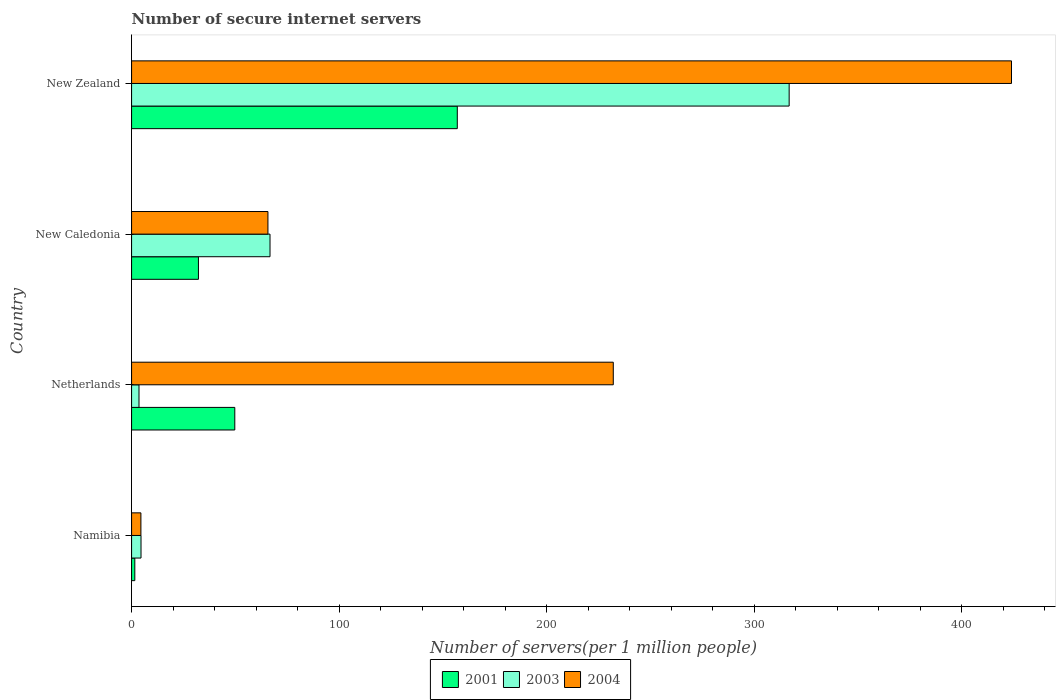How many different coloured bars are there?
Make the answer very short. 3. How many groups of bars are there?
Provide a short and direct response. 4. Are the number of bars per tick equal to the number of legend labels?
Offer a very short reply. Yes. Are the number of bars on each tick of the Y-axis equal?
Offer a terse response. Yes. What is the number of secure internet servers in 2001 in Netherlands?
Give a very brief answer. 49.73. Across all countries, what is the maximum number of secure internet servers in 2001?
Offer a very short reply. 156.94. Across all countries, what is the minimum number of secure internet servers in 2003?
Your answer should be compact. 3.57. In which country was the number of secure internet servers in 2004 maximum?
Provide a short and direct response. New Zealand. In which country was the number of secure internet servers in 2004 minimum?
Offer a very short reply. Namibia. What is the total number of secure internet servers in 2004 in the graph?
Your response must be concise. 726.27. What is the difference between the number of secure internet servers in 2004 in New Caledonia and that in New Zealand?
Make the answer very short. -358.27. What is the difference between the number of secure internet servers in 2003 in New Zealand and the number of secure internet servers in 2001 in Netherlands?
Offer a very short reply. 267.11. What is the average number of secure internet servers in 2001 per country?
Offer a terse response. 60.11. What is the difference between the number of secure internet servers in 2003 and number of secure internet servers in 2004 in Netherlands?
Provide a short and direct response. -228.53. In how many countries, is the number of secure internet servers in 2003 greater than 360 ?
Your answer should be very brief. 0. What is the ratio of the number of secure internet servers in 2004 in Namibia to that in New Zealand?
Give a very brief answer. 0.01. Is the number of secure internet servers in 2003 in Netherlands less than that in New Zealand?
Give a very brief answer. Yes. What is the difference between the highest and the second highest number of secure internet servers in 2004?
Make the answer very short. 191.88. What is the difference between the highest and the lowest number of secure internet servers in 2001?
Your answer should be very brief. 155.38. Are all the bars in the graph horizontal?
Offer a terse response. Yes. Where does the legend appear in the graph?
Offer a very short reply. Bottom center. How are the legend labels stacked?
Make the answer very short. Horizontal. What is the title of the graph?
Ensure brevity in your answer.  Number of secure internet servers. What is the label or title of the X-axis?
Give a very brief answer. Number of servers(per 1 million people). What is the Number of servers(per 1 million people) in 2001 in Namibia?
Ensure brevity in your answer.  1.55. What is the Number of servers(per 1 million people) in 2003 in Namibia?
Give a very brief answer. 4.54. What is the Number of servers(per 1 million people) of 2004 in Namibia?
Offer a very short reply. 4.49. What is the Number of servers(per 1 million people) in 2001 in Netherlands?
Provide a short and direct response. 49.73. What is the Number of servers(per 1 million people) of 2003 in Netherlands?
Keep it short and to the point. 3.57. What is the Number of servers(per 1 million people) in 2004 in Netherlands?
Make the answer very short. 232.1. What is the Number of servers(per 1 million people) in 2001 in New Caledonia?
Your response must be concise. 32.21. What is the Number of servers(per 1 million people) of 2003 in New Caledonia?
Keep it short and to the point. 66.71. What is the Number of servers(per 1 million people) in 2004 in New Caledonia?
Keep it short and to the point. 65.7. What is the Number of servers(per 1 million people) in 2001 in New Zealand?
Provide a succinct answer. 156.94. What is the Number of servers(per 1 million people) of 2003 in New Zealand?
Make the answer very short. 316.85. What is the Number of servers(per 1 million people) of 2004 in New Zealand?
Provide a short and direct response. 423.98. Across all countries, what is the maximum Number of servers(per 1 million people) in 2001?
Provide a succinct answer. 156.94. Across all countries, what is the maximum Number of servers(per 1 million people) of 2003?
Your answer should be very brief. 316.85. Across all countries, what is the maximum Number of servers(per 1 million people) of 2004?
Provide a short and direct response. 423.98. Across all countries, what is the minimum Number of servers(per 1 million people) in 2001?
Provide a succinct answer. 1.55. Across all countries, what is the minimum Number of servers(per 1 million people) in 2003?
Your answer should be compact. 3.57. Across all countries, what is the minimum Number of servers(per 1 million people) in 2004?
Make the answer very short. 4.49. What is the total Number of servers(per 1 million people) of 2001 in the graph?
Offer a terse response. 240.43. What is the total Number of servers(per 1 million people) in 2003 in the graph?
Your answer should be very brief. 391.67. What is the total Number of servers(per 1 million people) in 2004 in the graph?
Your answer should be compact. 726.27. What is the difference between the Number of servers(per 1 million people) in 2001 in Namibia and that in Netherlands?
Keep it short and to the point. -48.18. What is the difference between the Number of servers(per 1 million people) in 2003 in Namibia and that in Netherlands?
Provide a succinct answer. 0.97. What is the difference between the Number of servers(per 1 million people) in 2004 in Namibia and that in Netherlands?
Offer a very short reply. -227.61. What is the difference between the Number of servers(per 1 million people) of 2001 in Namibia and that in New Caledonia?
Offer a terse response. -30.66. What is the difference between the Number of servers(per 1 million people) of 2003 in Namibia and that in New Caledonia?
Offer a terse response. -62.16. What is the difference between the Number of servers(per 1 million people) of 2004 in Namibia and that in New Caledonia?
Provide a succinct answer. -61.21. What is the difference between the Number of servers(per 1 million people) of 2001 in Namibia and that in New Zealand?
Your response must be concise. -155.38. What is the difference between the Number of servers(per 1 million people) of 2003 in Namibia and that in New Zealand?
Your answer should be very brief. -312.3. What is the difference between the Number of servers(per 1 million people) of 2004 in Namibia and that in New Zealand?
Offer a very short reply. -419.48. What is the difference between the Number of servers(per 1 million people) in 2001 in Netherlands and that in New Caledonia?
Keep it short and to the point. 17.52. What is the difference between the Number of servers(per 1 million people) in 2003 in Netherlands and that in New Caledonia?
Offer a terse response. -63.13. What is the difference between the Number of servers(per 1 million people) in 2004 in Netherlands and that in New Caledonia?
Give a very brief answer. 166.4. What is the difference between the Number of servers(per 1 million people) in 2001 in Netherlands and that in New Zealand?
Keep it short and to the point. -107.21. What is the difference between the Number of servers(per 1 million people) of 2003 in Netherlands and that in New Zealand?
Provide a short and direct response. -313.27. What is the difference between the Number of servers(per 1 million people) in 2004 in Netherlands and that in New Zealand?
Offer a very short reply. -191.88. What is the difference between the Number of servers(per 1 million people) of 2001 in New Caledonia and that in New Zealand?
Ensure brevity in your answer.  -124.73. What is the difference between the Number of servers(per 1 million people) in 2003 in New Caledonia and that in New Zealand?
Offer a terse response. -250.14. What is the difference between the Number of servers(per 1 million people) in 2004 in New Caledonia and that in New Zealand?
Keep it short and to the point. -358.27. What is the difference between the Number of servers(per 1 million people) of 2001 in Namibia and the Number of servers(per 1 million people) of 2003 in Netherlands?
Ensure brevity in your answer.  -2.02. What is the difference between the Number of servers(per 1 million people) in 2001 in Namibia and the Number of servers(per 1 million people) in 2004 in Netherlands?
Provide a short and direct response. -230.55. What is the difference between the Number of servers(per 1 million people) of 2003 in Namibia and the Number of servers(per 1 million people) of 2004 in Netherlands?
Offer a very short reply. -227.56. What is the difference between the Number of servers(per 1 million people) of 2001 in Namibia and the Number of servers(per 1 million people) of 2003 in New Caledonia?
Ensure brevity in your answer.  -65.15. What is the difference between the Number of servers(per 1 million people) of 2001 in Namibia and the Number of servers(per 1 million people) of 2004 in New Caledonia?
Your answer should be compact. -64.15. What is the difference between the Number of servers(per 1 million people) in 2003 in Namibia and the Number of servers(per 1 million people) in 2004 in New Caledonia?
Your answer should be very brief. -61.16. What is the difference between the Number of servers(per 1 million people) in 2001 in Namibia and the Number of servers(per 1 million people) in 2003 in New Zealand?
Make the answer very short. -315.29. What is the difference between the Number of servers(per 1 million people) of 2001 in Namibia and the Number of servers(per 1 million people) of 2004 in New Zealand?
Your answer should be very brief. -422.42. What is the difference between the Number of servers(per 1 million people) in 2003 in Namibia and the Number of servers(per 1 million people) in 2004 in New Zealand?
Offer a terse response. -419.43. What is the difference between the Number of servers(per 1 million people) of 2001 in Netherlands and the Number of servers(per 1 million people) of 2003 in New Caledonia?
Keep it short and to the point. -16.97. What is the difference between the Number of servers(per 1 million people) of 2001 in Netherlands and the Number of servers(per 1 million people) of 2004 in New Caledonia?
Offer a very short reply. -15.97. What is the difference between the Number of servers(per 1 million people) in 2003 in Netherlands and the Number of servers(per 1 million people) in 2004 in New Caledonia?
Your answer should be very brief. -62.13. What is the difference between the Number of servers(per 1 million people) of 2001 in Netherlands and the Number of servers(per 1 million people) of 2003 in New Zealand?
Ensure brevity in your answer.  -267.11. What is the difference between the Number of servers(per 1 million people) in 2001 in Netherlands and the Number of servers(per 1 million people) in 2004 in New Zealand?
Keep it short and to the point. -374.24. What is the difference between the Number of servers(per 1 million people) of 2003 in Netherlands and the Number of servers(per 1 million people) of 2004 in New Zealand?
Your answer should be compact. -420.4. What is the difference between the Number of servers(per 1 million people) of 2001 in New Caledonia and the Number of servers(per 1 million people) of 2003 in New Zealand?
Give a very brief answer. -284.64. What is the difference between the Number of servers(per 1 million people) in 2001 in New Caledonia and the Number of servers(per 1 million people) in 2004 in New Zealand?
Ensure brevity in your answer.  -391.77. What is the difference between the Number of servers(per 1 million people) of 2003 in New Caledonia and the Number of servers(per 1 million people) of 2004 in New Zealand?
Make the answer very short. -357.27. What is the average Number of servers(per 1 million people) in 2001 per country?
Offer a terse response. 60.11. What is the average Number of servers(per 1 million people) of 2003 per country?
Keep it short and to the point. 97.92. What is the average Number of servers(per 1 million people) of 2004 per country?
Provide a short and direct response. 181.57. What is the difference between the Number of servers(per 1 million people) in 2001 and Number of servers(per 1 million people) in 2003 in Namibia?
Make the answer very short. -2.99. What is the difference between the Number of servers(per 1 million people) of 2001 and Number of servers(per 1 million people) of 2004 in Namibia?
Provide a short and direct response. -2.94. What is the difference between the Number of servers(per 1 million people) of 2003 and Number of servers(per 1 million people) of 2004 in Namibia?
Offer a terse response. 0.05. What is the difference between the Number of servers(per 1 million people) of 2001 and Number of servers(per 1 million people) of 2003 in Netherlands?
Your response must be concise. 46.16. What is the difference between the Number of servers(per 1 million people) of 2001 and Number of servers(per 1 million people) of 2004 in Netherlands?
Keep it short and to the point. -182.37. What is the difference between the Number of servers(per 1 million people) of 2003 and Number of servers(per 1 million people) of 2004 in Netherlands?
Offer a terse response. -228.53. What is the difference between the Number of servers(per 1 million people) in 2001 and Number of servers(per 1 million people) in 2003 in New Caledonia?
Your answer should be compact. -34.5. What is the difference between the Number of servers(per 1 million people) of 2001 and Number of servers(per 1 million people) of 2004 in New Caledonia?
Provide a short and direct response. -33.49. What is the difference between the Number of servers(per 1 million people) of 2001 and Number of servers(per 1 million people) of 2003 in New Zealand?
Provide a succinct answer. -159.91. What is the difference between the Number of servers(per 1 million people) of 2001 and Number of servers(per 1 million people) of 2004 in New Zealand?
Your answer should be very brief. -267.04. What is the difference between the Number of servers(per 1 million people) in 2003 and Number of servers(per 1 million people) in 2004 in New Zealand?
Provide a succinct answer. -107.13. What is the ratio of the Number of servers(per 1 million people) of 2001 in Namibia to that in Netherlands?
Your answer should be very brief. 0.03. What is the ratio of the Number of servers(per 1 million people) in 2003 in Namibia to that in Netherlands?
Your response must be concise. 1.27. What is the ratio of the Number of servers(per 1 million people) of 2004 in Namibia to that in Netherlands?
Ensure brevity in your answer.  0.02. What is the ratio of the Number of servers(per 1 million people) of 2001 in Namibia to that in New Caledonia?
Provide a short and direct response. 0.05. What is the ratio of the Number of servers(per 1 million people) of 2003 in Namibia to that in New Caledonia?
Your response must be concise. 0.07. What is the ratio of the Number of servers(per 1 million people) of 2004 in Namibia to that in New Caledonia?
Ensure brevity in your answer.  0.07. What is the ratio of the Number of servers(per 1 million people) of 2001 in Namibia to that in New Zealand?
Offer a terse response. 0.01. What is the ratio of the Number of servers(per 1 million people) in 2003 in Namibia to that in New Zealand?
Offer a terse response. 0.01. What is the ratio of the Number of servers(per 1 million people) of 2004 in Namibia to that in New Zealand?
Make the answer very short. 0.01. What is the ratio of the Number of servers(per 1 million people) of 2001 in Netherlands to that in New Caledonia?
Keep it short and to the point. 1.54. What is the ratio of the Number of servers(per 1 million people) in 2003 in Netherlands to that in New Caledonia?
Ensure brevity in your answer.  0.05. What is the ratio of the Number of servers(per 1 million people) of 2004 in Netherlands to that in New Caledonia?
Your answer should be compact. 3.53. What is the ratio of the Number of servers(per 1 million people) in 2001 in Netherlands to that in New Zealand?
Your answer should be very brief. 0.32. What is the ratio of the Number of servers(per 1 million people) of 2003 in Netherlands to that in New Zealand?
Offer a terse response. 0.01. What is the ratio of the Number of servers(per 1 million people) in 2004 in Netherlands to that in New Zealand?
Your response must be concise. 0.55. What is the ratio of the Number of servers(per 1 million people) in 2001 in New Caledonia to that in New Zealand?
Make the answer very short. 0.21. What is the ratio of the Number of servers(per 1 million people) in 2003 in New Caledonia to that in New Zealand?
Provide a short and direct response. 0.21. What is the ratio of the Number of servers(per 1 million people) in 2004 in New Caledonia to that in New Zealand?
Your response must be concise. 0.15. What is the difference between the highest and the second highest Number of servers(per 1 million people) of 2001?
Your answer should be compact. 107.21. What is the difference between the highest and the second highest Number of servers(per 1 million people) in 2003?
Your answer should be compact. 250.14. What is the difference between the highest and the second highest Number of servers(per 1 million people) of 2004?
Make the answer very short. 191.88. What is the difference between the highest and the lowest Number of servers(per 1 million people) in 2001?
Give a very brief answer. 155.38. What is the difference between the highest and the lowest Number of servers(per 1 million people) of 2003?
Keep it short and to the point. 313.27. What is the difference between the highest and the lowest Number of servers(per 1 million people) in 2004?
Your response must be concise. 419.48. 